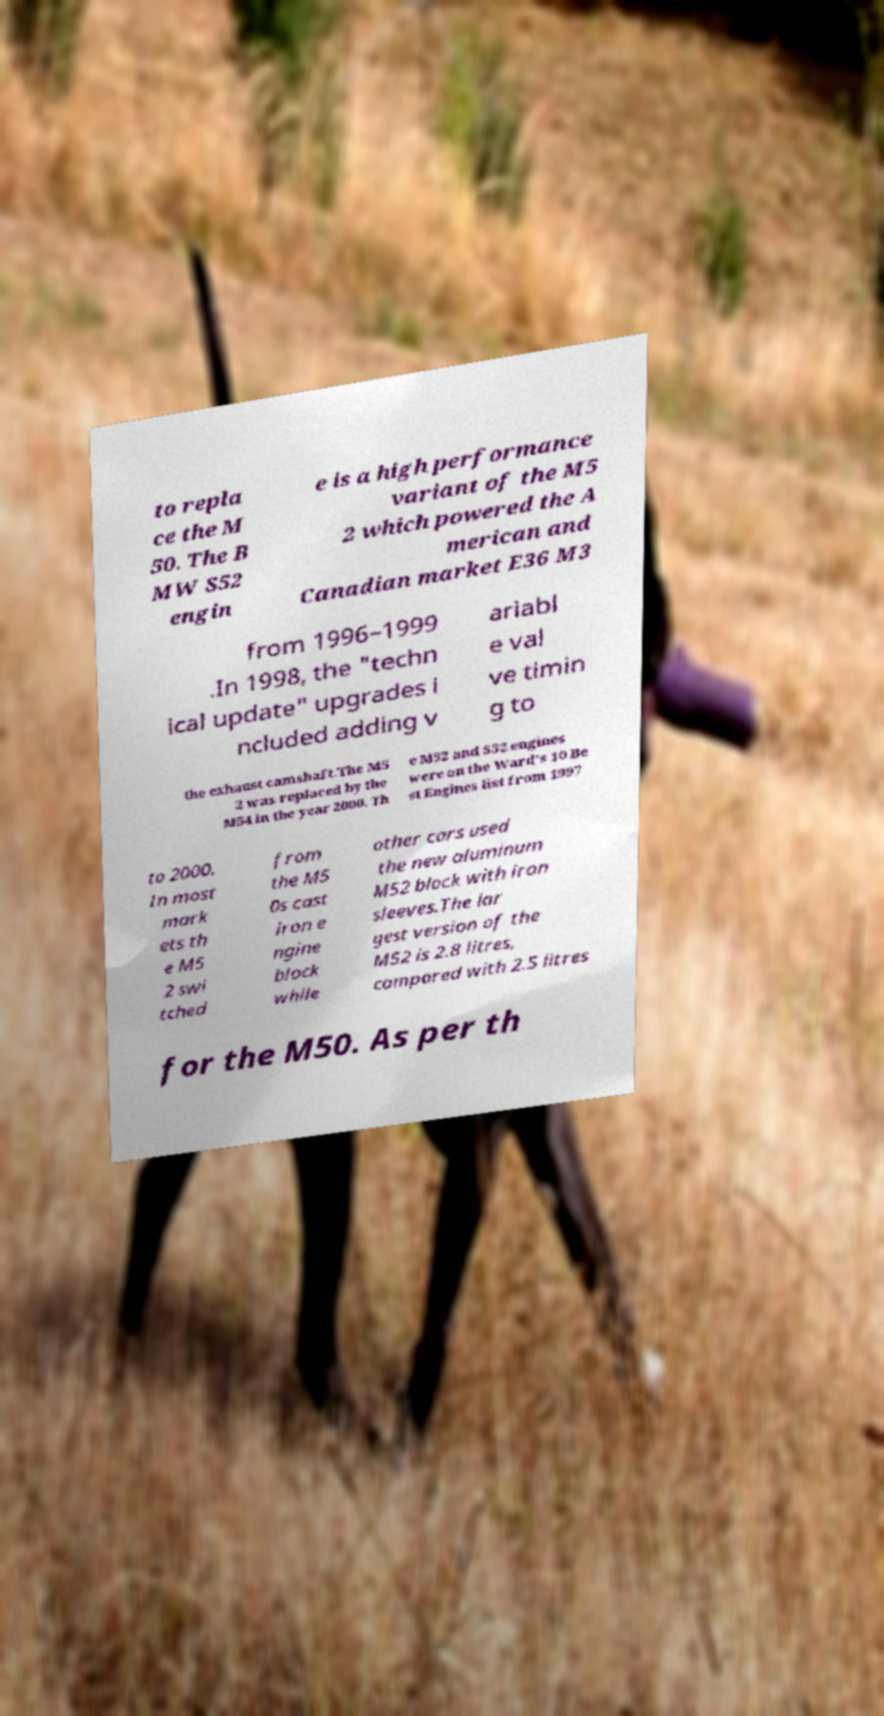What messages or text are displayed in this image? I need them in a readable, typed format. to repla ce the M 50. The B MW S52 engin e is a high performance variant of the M5 2 which powered the A merican and Canadian market E36 M3 from 1996–1999 .In 1998, the "techn ical update" upgrades i ncluded adding v ariabl e val ve timin g to the exhaust camshaft.The M5 2 was replaced by the M54 in the year 2000. Th e M52 and S52 engines were on the Ward's 10 Be st Engines list from 1997 to 2000. In most mark ets th e M5 2 swi tched from the M5 0s cast iron e ngine block while other cars used the new aluminum M52 block with iron sleeves.The lar gest version of the M52 is 2.8 litres, compared with 2.5 litres for the M50. As per th 